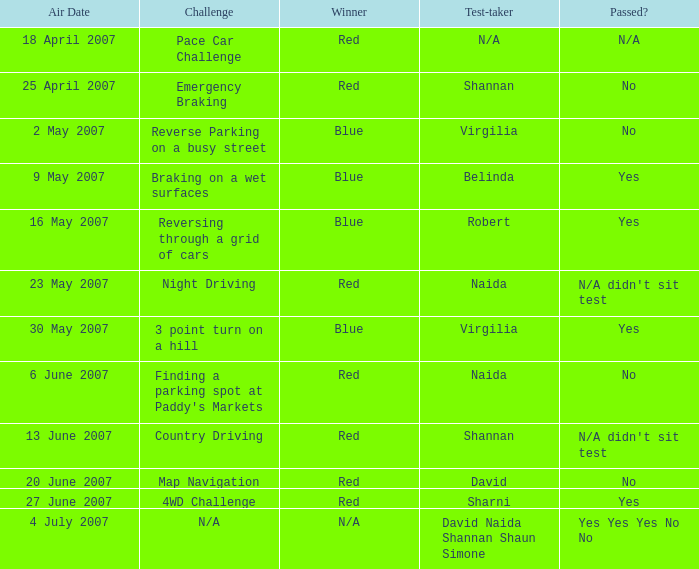What air date has a red winner and an emergency braking challenge? 25 April 2007. 